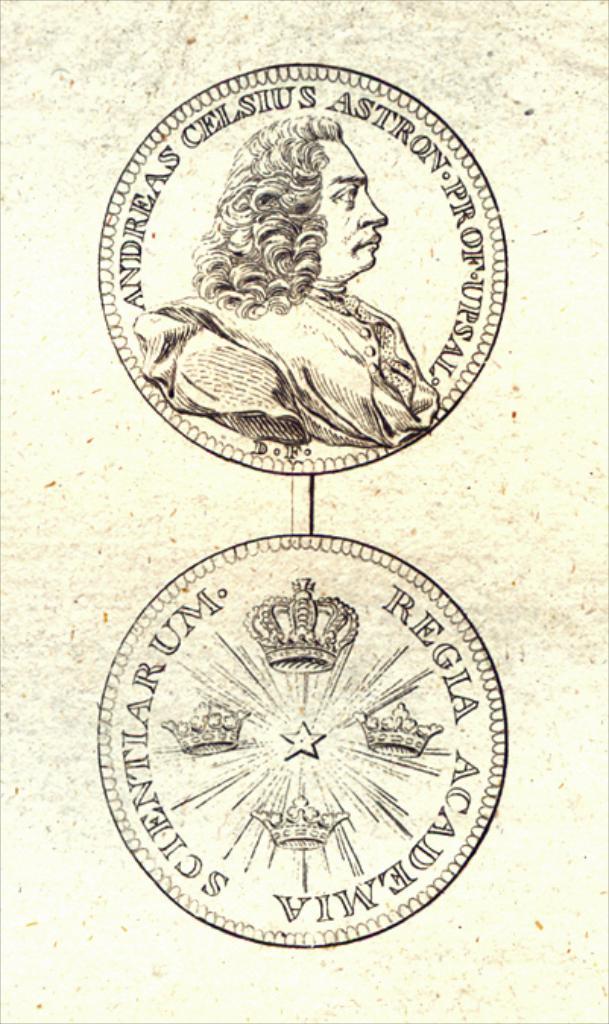In one or two sentences, can you explain what this image depicts? There are two logos. On the first logo there is a picture of a person and something is written. On the second logo there are crowns and something is written. 